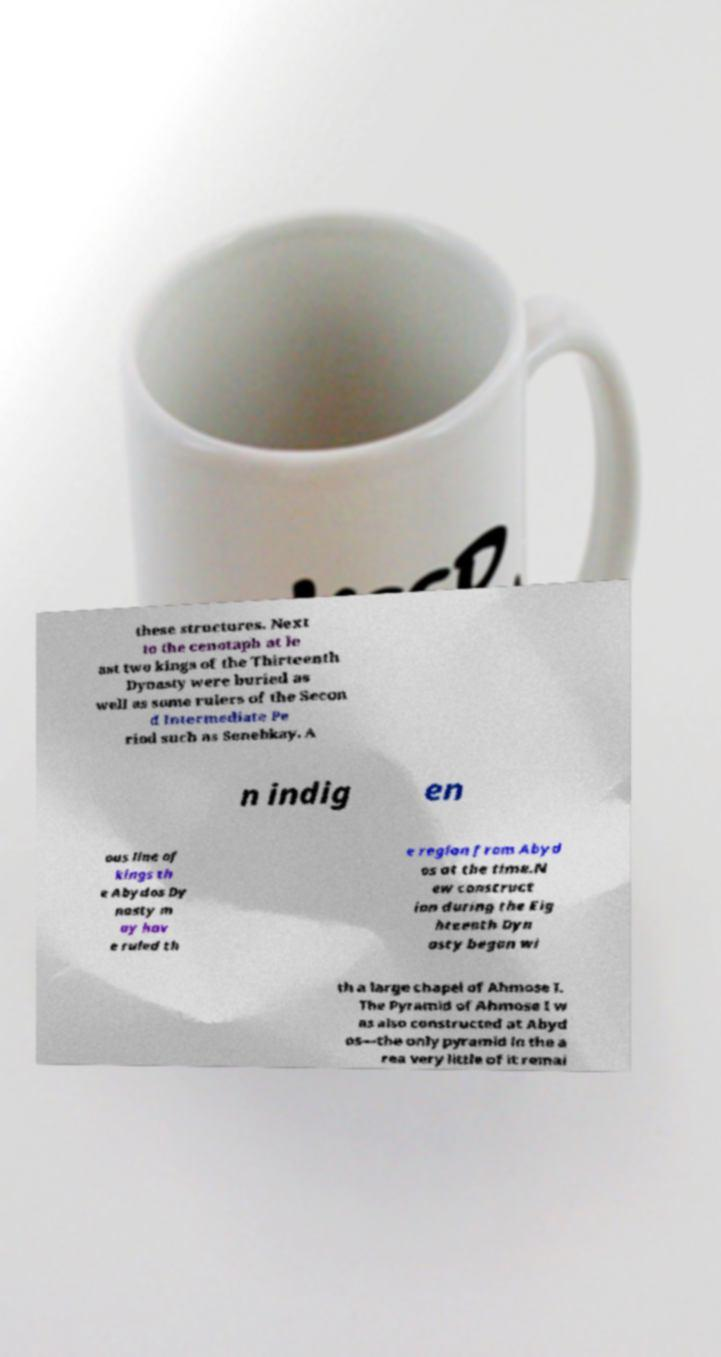Could you extract and type out the text from this image? these structures. Next to the cenotaph at le ast two kings of the Thirteenth Dynasty were buried as well as some rulers of the Secon d Intermediate Pe riod such as Senebkay. A n indig en ous line of kings th e Abydos Dy nasty m ay hav e ruled th e region from Abyd os at the time.N ew construct ion during the Eig hteenth Dyn asty began wi th a large chapel of Ahmose I. The Pyramid of Ahmose I w as also constructed at Abyd os—the only pyramid in the a rea very little of it remai 